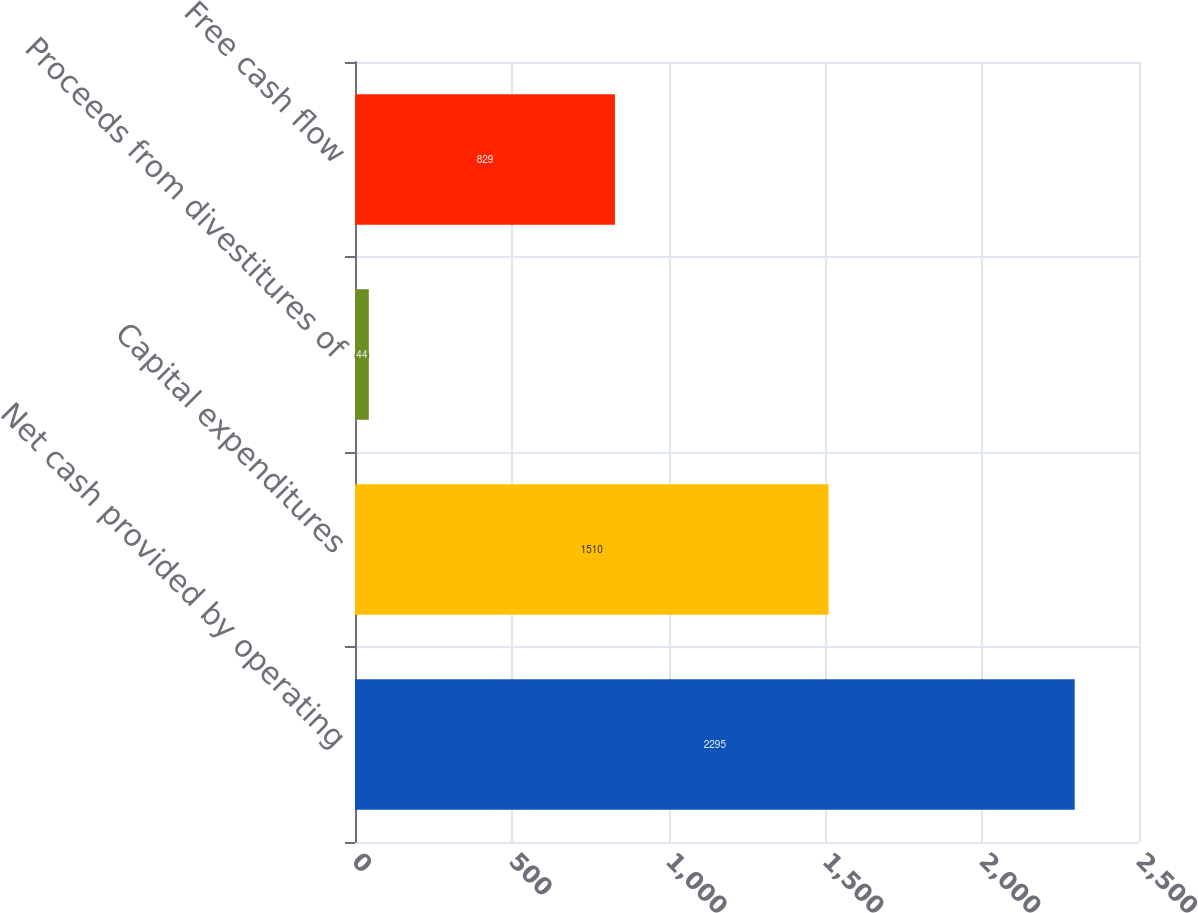<chart> <loc_0><loc_0><loc_500><loc_500><bar_chart><fcel>Net cash provided by operating<fcel>Capital expenditures<fcel>Proceeds from divestitures of<fcel>Free cash flow<nl><fcel>2295<fcel>1510<fcel>44<fcel>829<nl></chart> 